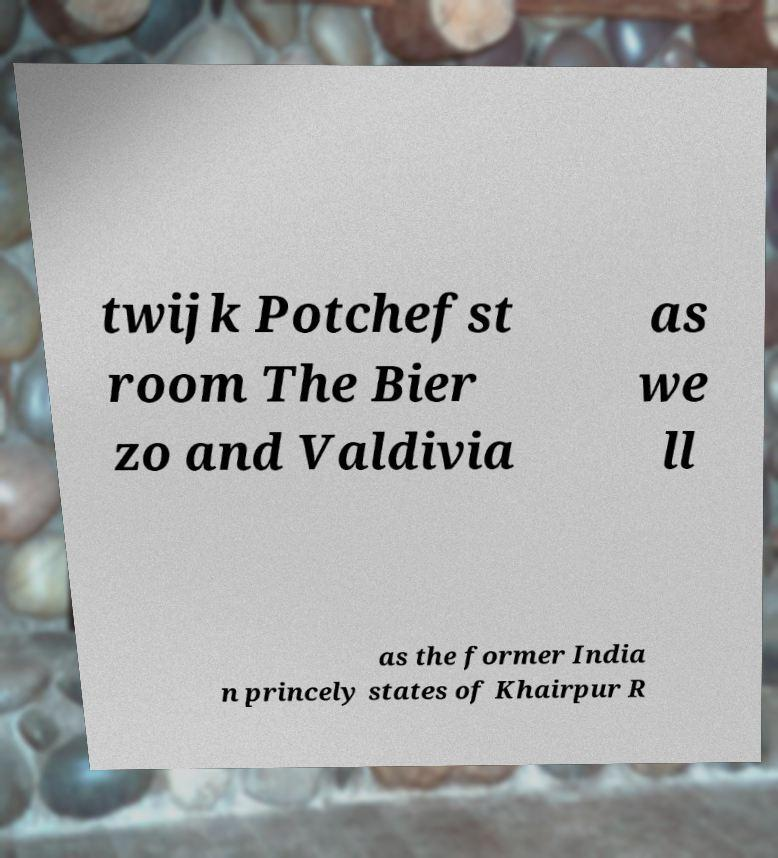There's text embedded in this image that I need extracted. Can you transcribe it verbatim? twijk Potchefst room The Bier zo and Valdivia as we ll as the former India n princely states of Khairpur R 